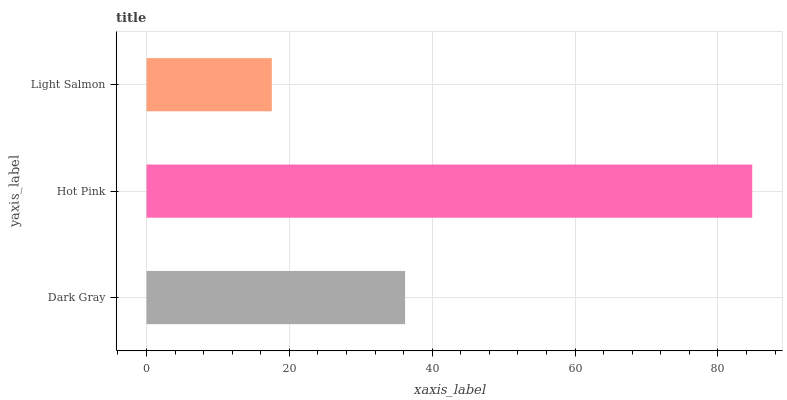Is Light Salmon the minimum?
Answer yes or no. Yes. Is Hot Pink the maximum?
Answer yes or no. Yes. Is Hot Pink the minimum?
Answer yes or no. No. Is Light Salmon the maximum?
Answer yes or no. No. Is Hot Pink greater than Light Salmon?
Answer yes or no. Yes. Is Light Salmon less than Hot Pink?
Answer yes or no. Yes. Is Light Salmon greater than Hot Pink?
Answer yes or no. No. Is Hot Pink less than Light Salmon?
Answer yes or no. No. Is Dark Gray the high median?
Answer yes or no. Yes. Is Dark Gray the low median?
Answer yes or no. Yes. Is Hot Pink the high median?
Answer yes or no. No. Is Hot Pink the low median?
Answer yes or no. No. 